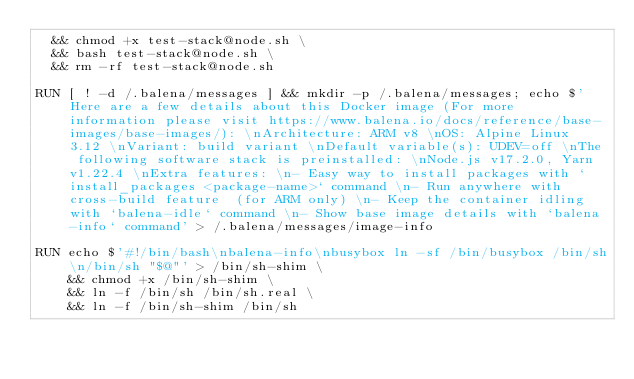<code> <loc_0><loc_0><loc_500><loc_500><_Dockerfile_>  && chmod +x test-stack@node.sh \
  && bash test-stack@node.sh \
  && rm -rf test-stack@node.sh 

RUN [ ! -d /.balena/messages ] && mkdir -p /.balena/messages; echo $'Here are a few details about this Docker image (For more information please visit https://www.balena.io/docs/reference/base-images/base-images/): \nArchitecture: ARM v8 \nOS: Alpine Linux 3.12 \nVariant: build variant \nDefault variable(s): UDEV=off \nThe following software stack is preinstalled: \nNode.js v17.2.0, Yarn v1.22.4 \nExtra features: \n- Easy way to install packages with `install_packages <package-name>` command \n- Run anywhere with cross-build feature  (for ARM only) \n- Keep the container idling with `balena-idle` command \n- Show base image details with `balena-info` command' > /.balena/messages/image-info

RUN echo $'#!/bin/bash\nbalena-info\nbusybox ln -sf /bin/busybox /bin/sh\n/bin/sh "$@"' > /bin/sh-shim \
	&& chmod +x /bin/sh-shim \
	&& ln -f /bin/sh /bin/sh.real \
	&& ln -f /bin/sh-shim /bin/sh</code> 